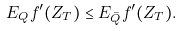Convert formula to latex. <formula><loc_0><loc_0><loc_500><loc_500>E _ { Q } f ^ { \prime } ( Z _ { T } ) \leq E _ { \bar { Q } } f ^ { \prime } ( Z _ { T } ) .</formula> 